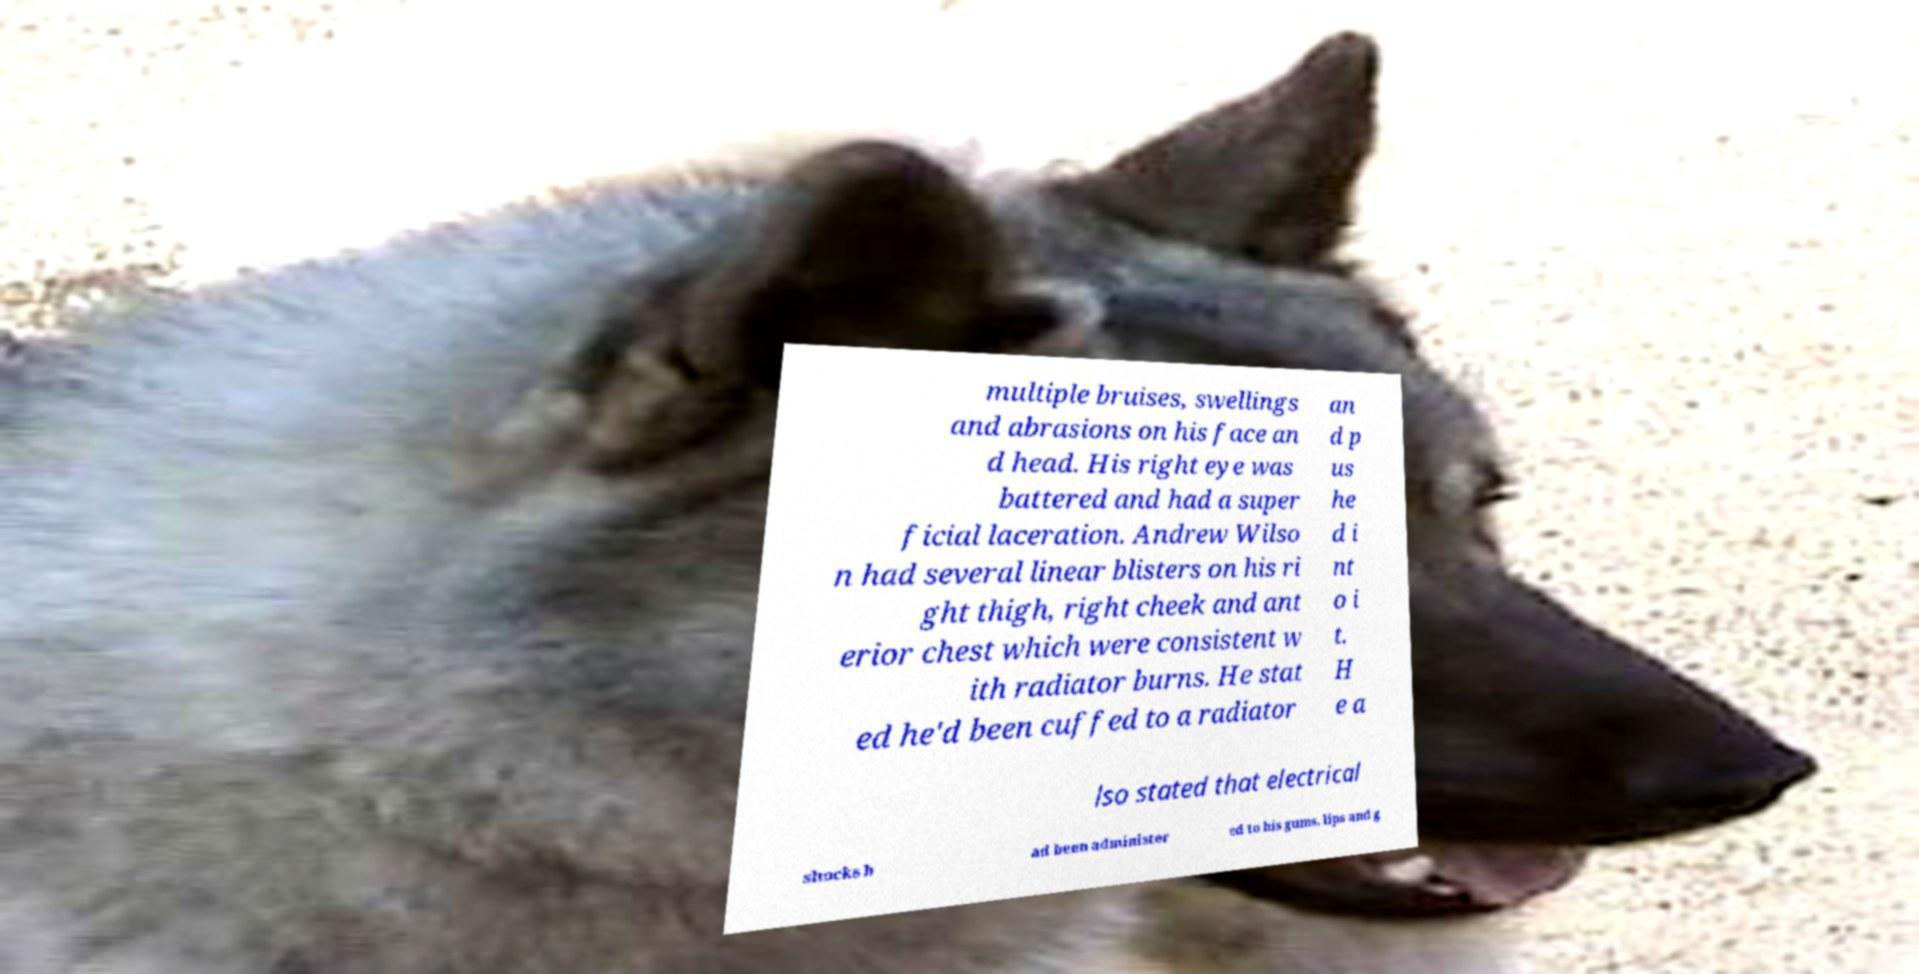Please identify and transcribe the text found in this image. multiple bruises, swellings and abrasions on his face an d head. His right eye was battered and had a super ficial laceration. Andrew Wilso n had several linear blisters on his ri ght thigh, right cheek and ant erior chest which were consistent w ith radiator burns. He stat ed he'd been cuffed to a radiator an d p us he d i nt o i t. H e a lso stated that electrical shocks h ad been administer ed to his gums, lips and g 